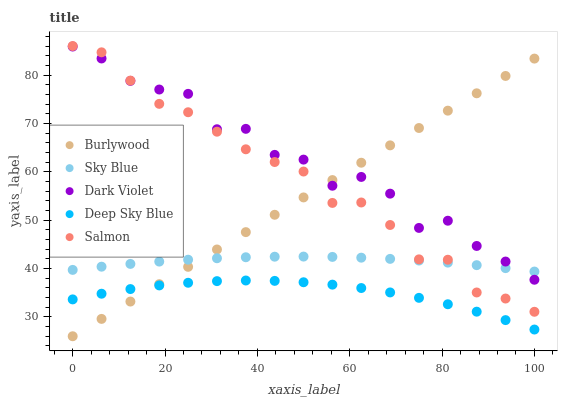Does Deep Sky Blue have the minimum area under the curve?
Answer yes or no. Yes. Does Dark Violet have the maximum area under the curve?
Answer yes or no. Yes. Does Sky Blue have the minimum area under the curve?
Answer yes or no. No. Does Sky Blue have the maximum area under the curve?
Answer yes or no. No. Is Burlywood the smoothest?
Answer yes or no. Yes. Is Dark Violet the roughest?
Answer yes or no. Yes. Is Sky Blue the smoothest?
Answer yes or no. No. Is Sky Blue the roughest?
Answer yes or no. No. Does Burlywood have the lowest value?
Answer yes or no. Yes. Does Salmon have the lowest value?
Answer yes or no. No. Does Salmon have the highest value?
Answer yes or no. Yes. Does Sky Blue have the highest value?
Answer yes or no. No. Is Deep Sky Blue less than Sky Blue?
Answer yes or no. Yes. Is Salmon greater than Deep Sky Blue?
Answer yes or no. Yes. Does Dark Violet intersect Sky Blue?
Answer yes or no. Yes. Is Dark Violet less than Sky Blue?
Answer yes or no. No. Is Dark Violet greater than Sky Blue?
Answer yes or no. No. Does Deep Sky Blue intersect Sky Blue?
Answer yes or no. No. 